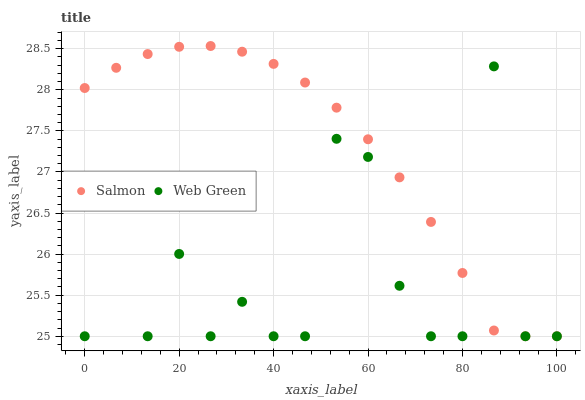Does Web Green have the minimum area under the curve?
Answer yes or no. Yes. Does Salmon have the maximum area under the curve?
Answer yes or no. Yes. Does Web Green have the maximum area under the curve?
Answer yes or no. No. Is Salmon the smoothest?
Answer yes or no. Yes. Is Web Green the roughest?
Answer yes or no. Yes. Is Web Green the smoothest?
Answer yes or no. No. Does Salmon have the lowest value?
Answer yes or no. Yes. Does Salmon have the highest value?
Answer yes or no. Yes. Does Web Green have the highest value?
Answer yes or no. No. Does Web Green intersect Salmon?
Answer yes or no. Yes. Is Web Green less than Salmon?
Answer yes or no. No. Is Web Green greater than Salmon?
Answer yes or no. No. 